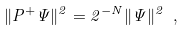Convert formula to latex. <formula><loc_0><loc_0><loc_500><loc_500>\| P ^ { + } \Psi \| ^ { 2 } = 2 ^ { - N } \| \Psi \| ^ { 2 } \ ,</formula> 